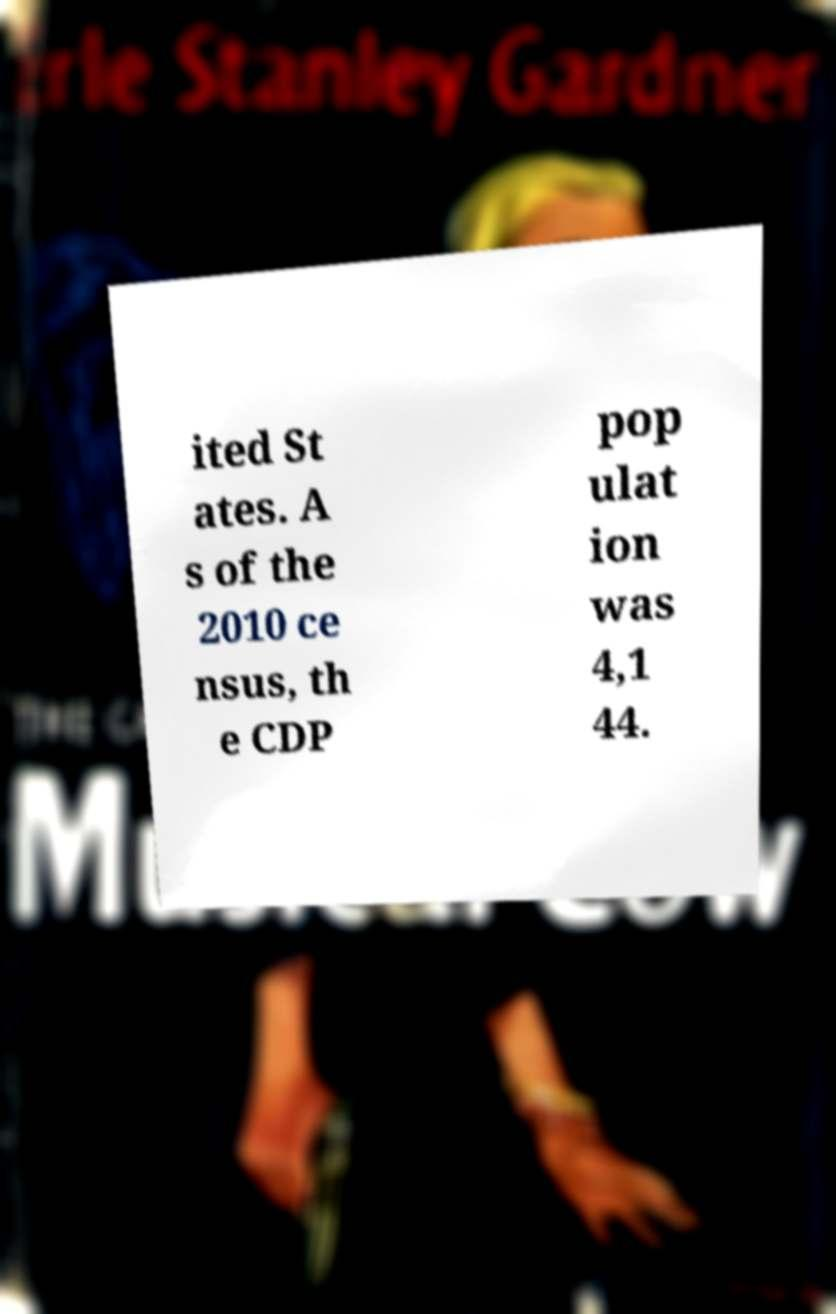I need the written content from this picture converted into text. Can you do that? ited St ates. A s of the 2010 ce nsus, th e CDP pop ulat ion was 4,1 44. 